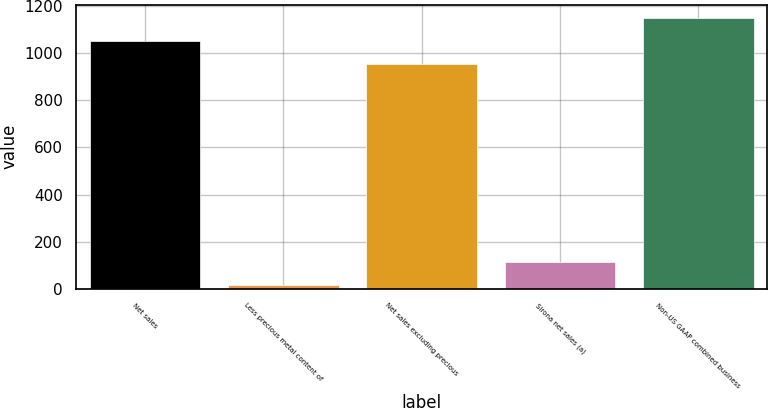<chart> <loc_0><loc_0><loc_500><loc_500><bar_chart><fcel>Net sales<fcel>Less precious metal content of<fcel>Net sales excluding precious<fcel>Sirona net sales (a)<fcel>Non-US GAAP combined business<nl><fcel>1050.51<fcel>17.6<fcel>952.9<fcel>115.21<fcel>1148.12<nl></chart> 